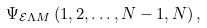<formula> <loc_0><loc_0><loc_500><loc_500>\Psi _ { \mathcal { E } \Lambda M } \left ( 1 , 2 , \dots , N - 1 , N \right ) ,</formula> 